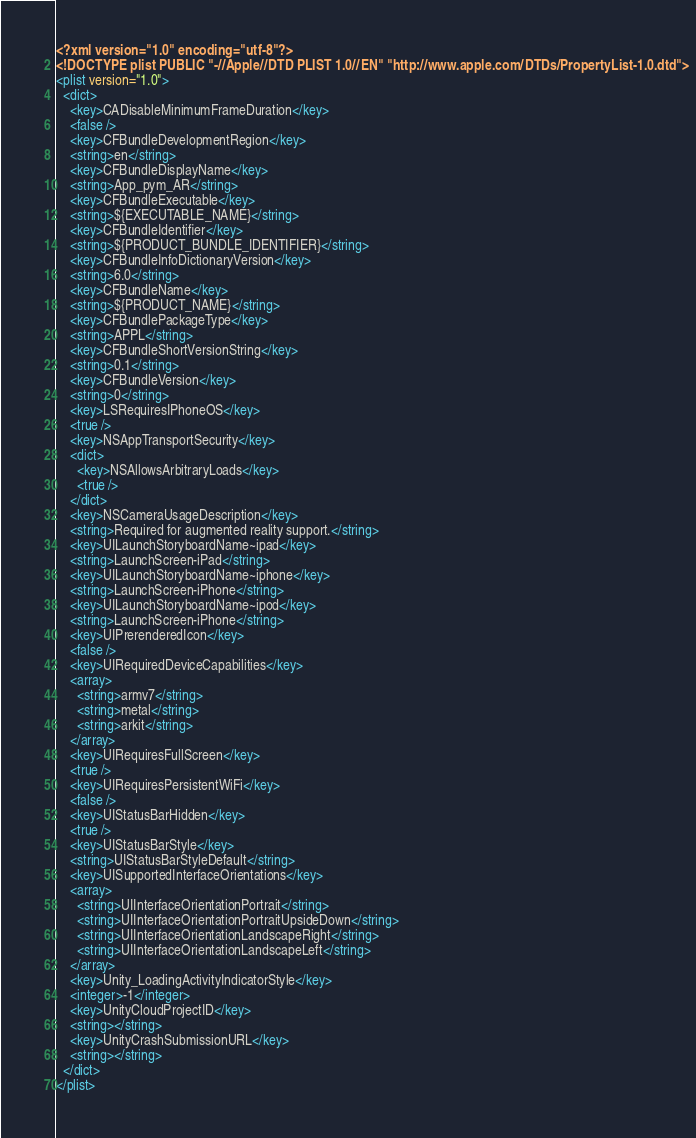<code> <loc_0><loc_0><loc_500><loc_500><_XML_><?xml version="1.0" encoding="utf-8"?>
<!DOCTYPE plist PUBLIC "-//Apple//DTD PLIST 1.0//EN" "http://www.apple.com/DTDs/PropertyList-1.0.dtd">
<plist version="1.0">
  <dict>
    <key>CADisableMinimumFrameDuration</key>
    <false />
    <key>CFBundleDevelopmentRegion</key>
    <string>en</string>
    <key>CFBundleDisplayName</key>
    <string>App_pym_AR</string>
    <key>CFBundleExecutable</key>
    <string>${EXECUTABLE_NAME}</string>
    <key>CFBundleIdentifier</key>
    <string>${PRODUCT_BUNDLE_IDENTIFIER}</string>
    <key>CFBundleInfoDictionaryVersion</key>
    <string>6.0</string>
    <key>CFBundleName</key>
    <string>${PRODUCT_NAME}</string>
    <key>CFBundlePackageType</key>
    <string>APPL</string>
    <key>CFBundleShortVersionString</key>
    <string>0.1</string>
    <key>CFBundleVersion</key>
    <string>0</string>
    <key>LSRequiresIPhoneOS</key>
    <true />
    <key>NSAppTransportSecurity</key>
    <dict>
      <key>NSAllowsArbitraryLoads</key>
      <true />
    </dict>
    <key>NSCameraUsageDescription</key>
    <string>Required for augmented reality support.</string>
    <key>UILaunchStoryboardName~ipad</key>
    <string>LaunchScreen-iPad</string>
    <key>UILaunchStoryboardName~iphone</key>
    <string>LaunchScreen-iPhone</string>
    <key>UILaunchStoryboardName~ipod</key>
    <string>LaunchScreen-iPhone</string>
    <key>UIPrerenderedIcon</key>
    <false />
    <key>UIRequiredDeviceCapabilities</key>
    <array>
      <string>armv7</string>
      <string>metal</string>
      <string>arkit</string>
    </array>
    <key>UIRequiresFullScreen</key>
    <true />
    <key>UIRequiresPersistentWiFi</key>
    <false />
    <key>UIStatusBarHidden</key>
    <true />
    <key>UIStatusBarStyle</key>
    <string>UIStatusBarStyleDefault</string>
    <key>UISupportedInterfaceOrientations</key>
    <array>
      <string>UIInterfaceOrientationPortrait</string>
      <string>UIInterfaceOrientationPortraitUpsideDown</string>
      <string>UIInterfaceOrientationLandscapeRight</string>
      <string>UIInterfaceOrientationLandscapeLeft</string>
    </array>
    <key>Unity_LoadingActivityIndicatorStyle</key>
    <integer>-1</integer>
    <key>UnityCloudProjectID</key>
    <string></string>
    <key>UnityCrashSubmissionURL</key>
    <string></string>
  </dict>
</plist>
</code> 